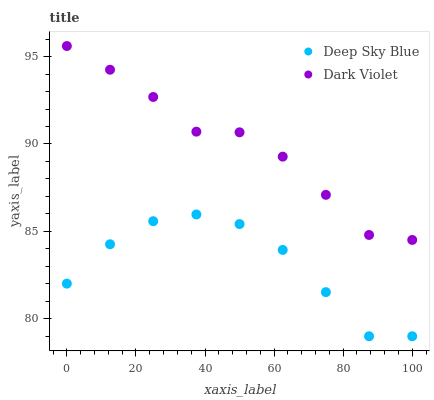Does Deep Sky Blue have the minimum area under the curve?
Answer yes or no. Yes. Does Dark Violet have the maximum area under the curve?
Answer yes or no. Yes. Does Deep Sky Blue have the maximum area under the curve?
Answer yes or no. No. Is Dark Violet the smoothest?
Answer yes or no. Yes. Is Deep Sky Blue the roughest?
Answer yes or no. Yes. Is Deep Sky Blue the smoothest?
Answer yes or no. No. Does Deep Sky Blue have the lowest value?
Answer yes or no. Yes. Does Dark Violet have the highest value?
Answer yes or no. Yes. Does Deep Sky Blue have the highest value?
Answer yes or no. No. Is Deep Sky Blue less than Dark Violet?
Answer yes or no. Yes. Is Dark Violet greater than Deep Sky Blue?
Answer yes or no. Yes. Does Deep Sky Blue intersect Dark Violet?
Answer yes or no. No. 